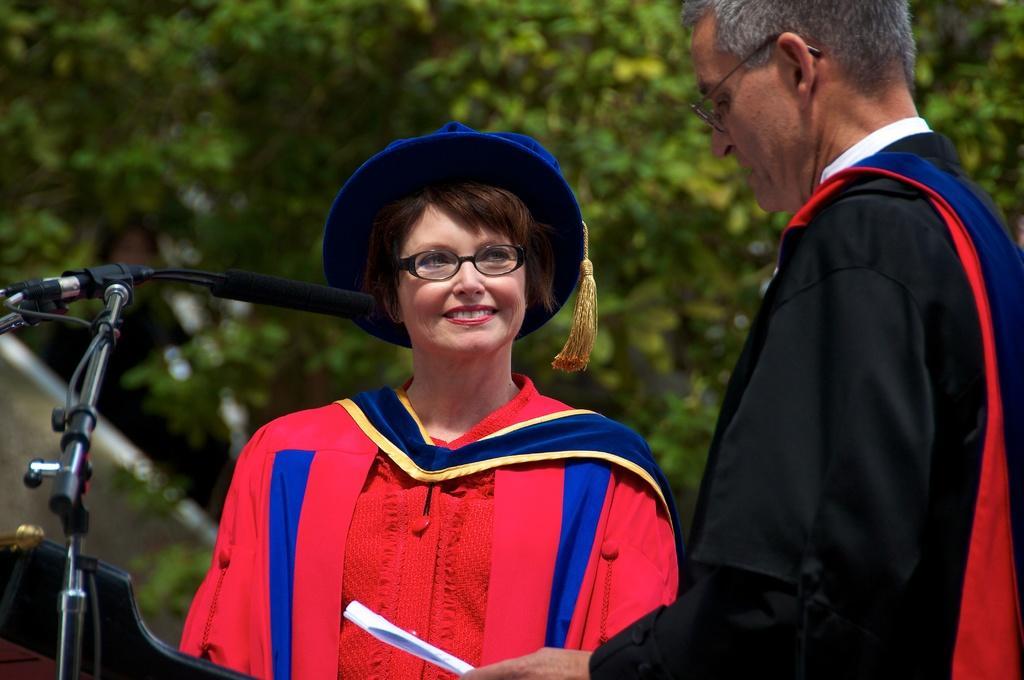Can you describe this image briefly? In this picture there is a woman standing in the front and wearing red color convocation dress, standing in front and looking to the old man wearing black dress. On the left side we can see the microphone stand. In the background there are some trees. 